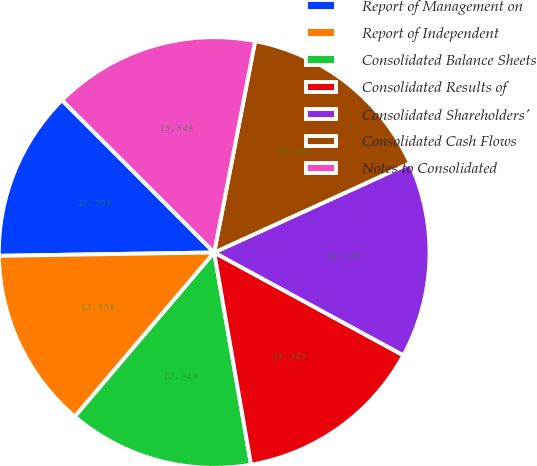<chart> <loc_0><loc_0><loc_500><loc_500><pie_chart><fcel>Report of Management on<fcel>Report of Independent<fcel>Consolidated Balance Sheets<fcel>Consolidated Results of<fcel>Consolidated Shareholders'<fcel>Consolidated Cash Flows<fcel>Notes to Consolidated<nl><fcel>12.75%<fcel>13.55%<fcel>13.94%<fcel>14.34%<fcel>14.74%<fcel>15.14%<fcel>15.54%<nl></chart> 